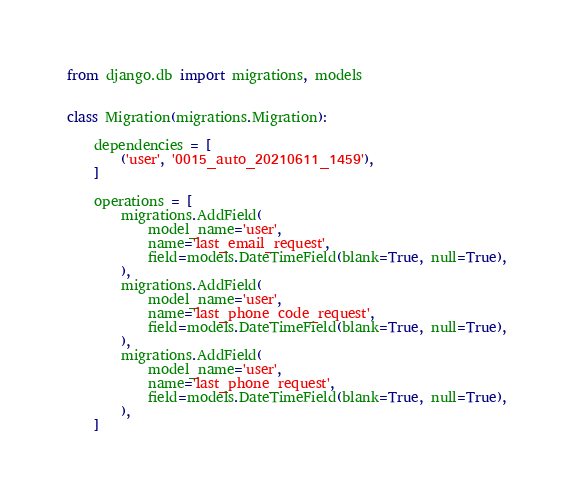Convert code to text. <code><loc_0><loc_0><loc_500><loc_500><_Python_>
from django.db import migrations, models


class Migration(migrations.Migration):

    dependencies = [
        ('user', '0015_auto_20210611_1459'),
    ]

    operations = [
        migrations.AddField(
            model_name='user',
            name='last_email_request',
            field=models.DateTimeField(blank=True, null=True),
        ),
        migrations.AddField(
            model_name='user',
            name='last_phone_code_request',
            field=models.DateTimeField(blank=True, null=True),
        ),
        migrations.AddField(
            model_name='user',
            name='last_phone_request',
            field=models.DateTimeField(blank=True, null=True),
        ),
    ]
</code> 